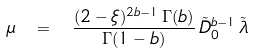Convert formula to latex. <formula><loc_0><loc_0><loc_500><loc_500>\mu \ = \ \frac { ( 2 - \xi ) ^ { 2 b - 1 } \, \Gamma ( b ) } { \Gamma ( 1 - b ) } \, \tilde { D } _ { 0 } ^ { b - 1 } \, \tilde { \lambda }</formula> 